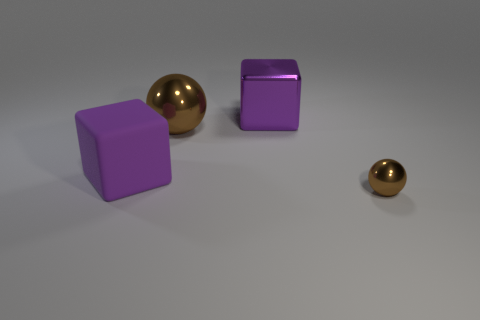There is a brown shiny object that is behind the small brown ball; is it the same shape as the small brown object?
Your answer should be very brief. Yes. What is the color of the large shiny thing to the right of the large metal sphere?
Ensure brevity in your answer.  Purple. How many other objects are the same size as the rubber thing?
Provide a short and direct response. 2. Are there any other things that are the same shape as the small shiny object?
Provide a succinct answer. Yes. Are there an equal number of shiny spheres that are in front of the tiny brown shiny ball and small yellow balls?
Provide a short and direct response. Yes. How many other brown balls are the same material as the big sphere?
Your answer should be very brief. 1. There is a block that is made of the same material as the tiny brown thing; what color is it?
Give a very brief answer. Purple. Is the large purple shiny object the same shape as the tiny brown object?
Offer a very short reply. No. Are there any small things that are behind the metallic sphere in front of the sphere behind the small thing?
Your answer should be very brief. No. How many other blocks are the same color as the large rubber cube?
Offer a terse response. 1. 